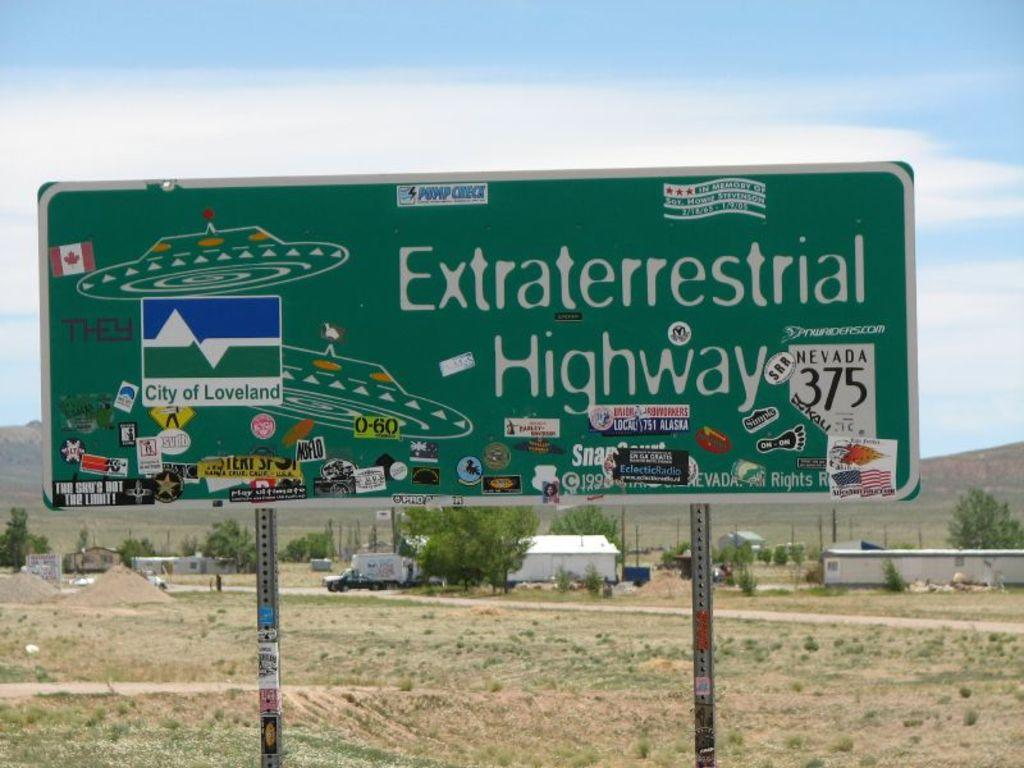<image>
Provide a brief description of the given image. a sign that has the word highway on ut 